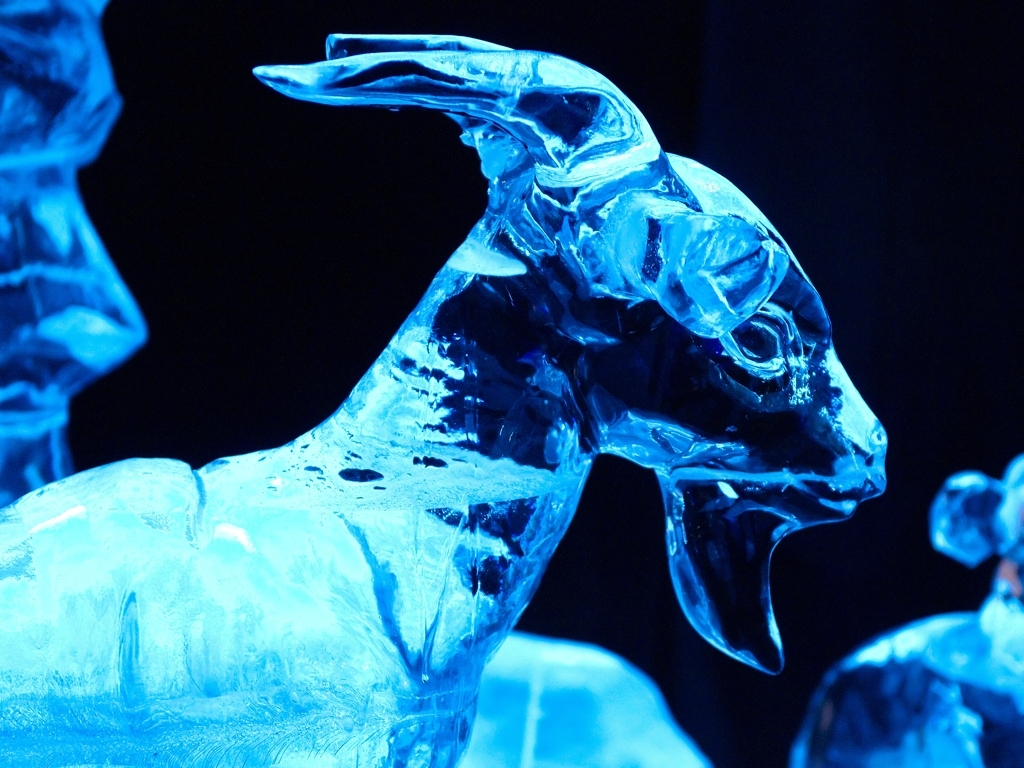Does the photographed subject retain certain texture details?
A. No
B. Yes
Answer with the option's letter from the given choices directly.
 B. 